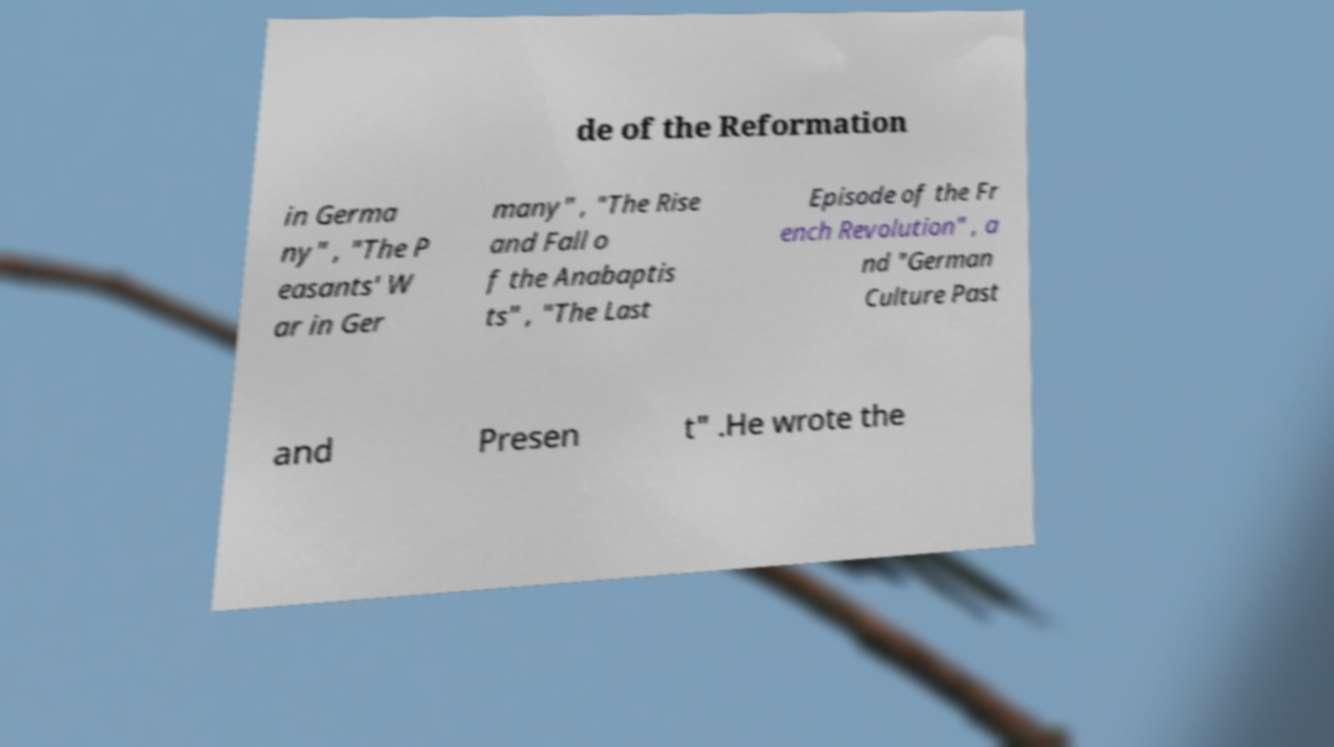I need the written content from this picture converted into text. Can you do that? de of the Reformation in Germa ny" , "The P easants' W ar in Ger many" , "The Rise and Fall o f the Anabaptis ts" , "The Last Episode of the Fr ench Revolution" , a nd "German Culture Past and Presen t" .He wrote the 